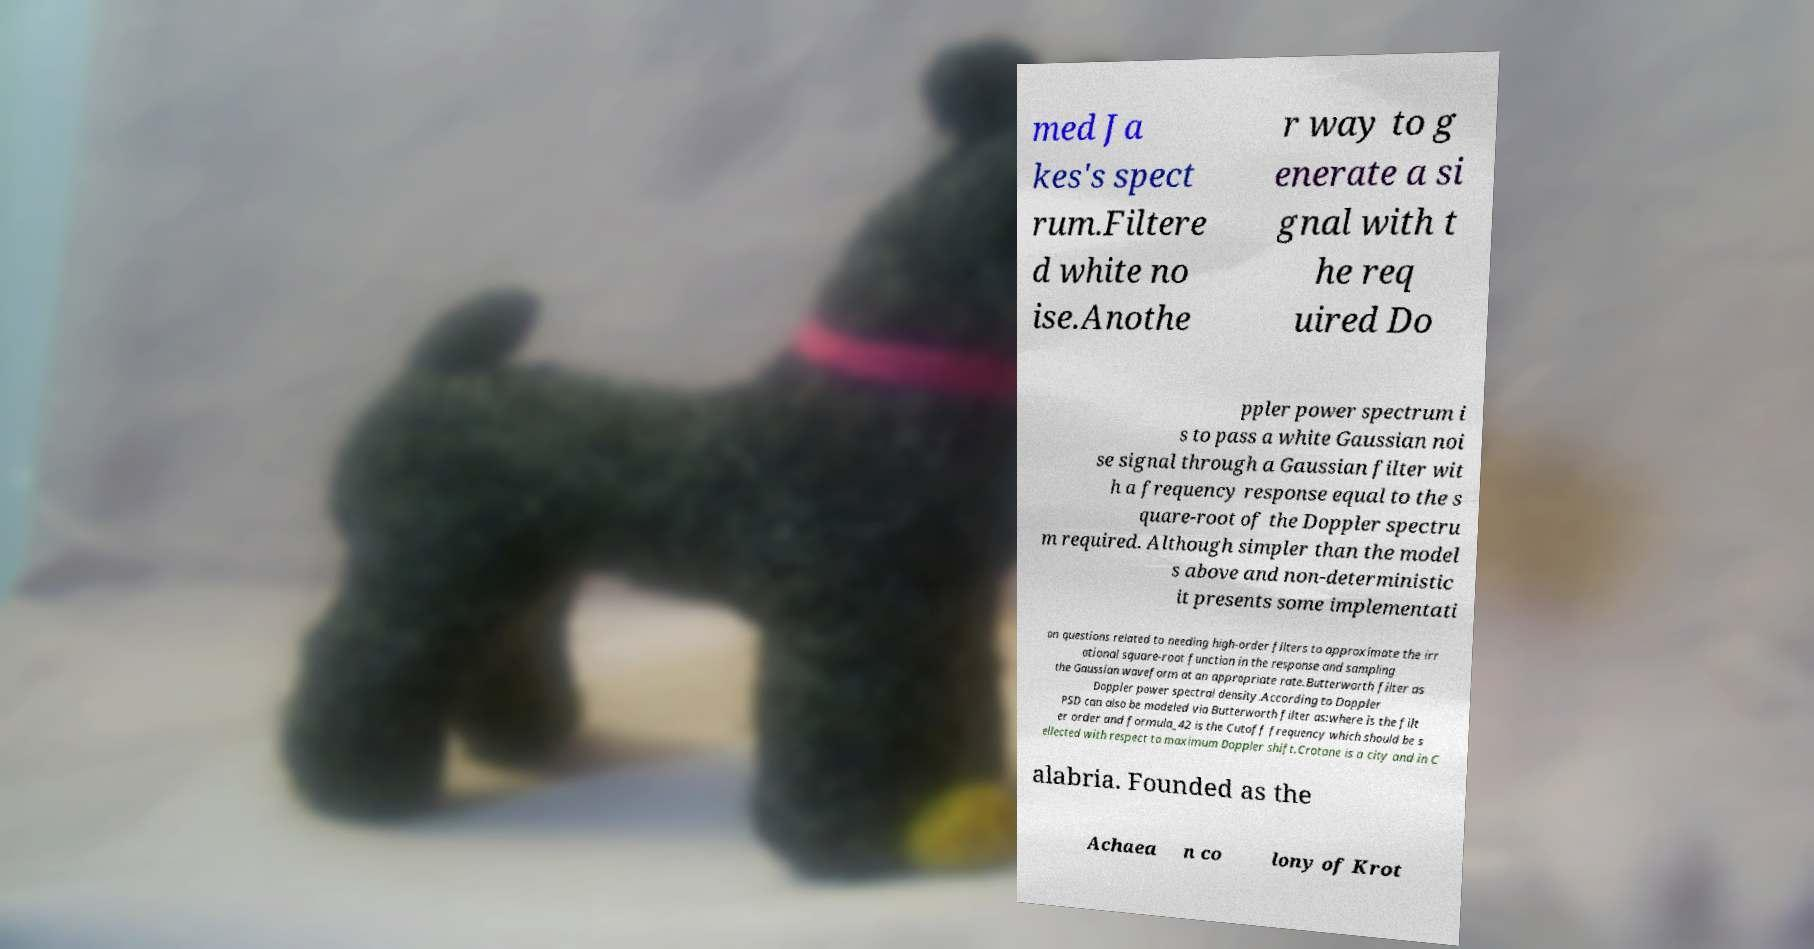Please identify and transcribe the text found in this image. med Ja kes's spect rum.Filtere d white no ise.Anothe r way to g enerate a si gnal with t he req uired Do ppler power spectrum i s to pass a white Gaussian noi se signal through a Gaussian filter wit h a frequency response equal to the s quare-root of the Doppler spectru m required. Although simpler than the model s above and non-deterministic it presents some implementati on questions related to needing high-order filters to approximate the irr ational square-root function in the response and sampling the Gaussian waveform at an appropriate rate.Butterworth filter as Doppler power spectral density.According to Doppler PSD can also be modeled via Butterworth filter as:where is the filt er order and formula_42 is the Cutoff frequency which should be s ellected with respect to maximum Doppler shift.Crotone is a city and in C alabria. Founded as the Achaea n co lony of Krot 